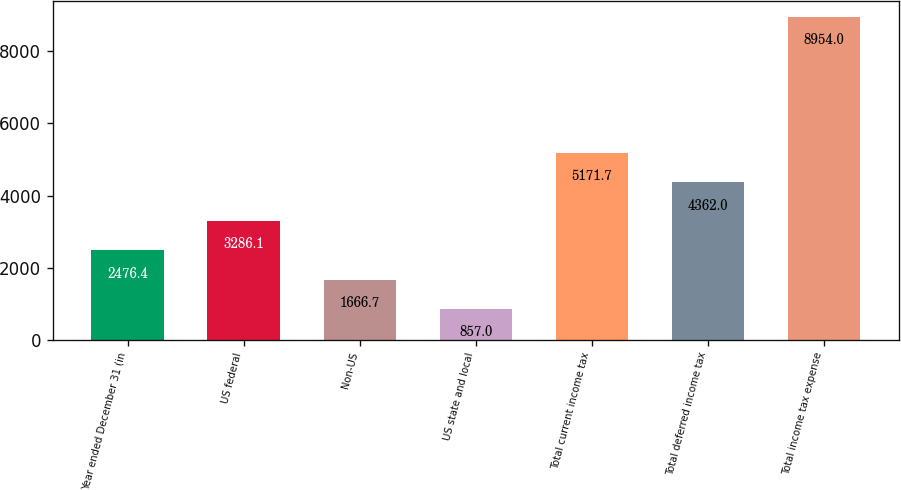<chart> <loc_0><loc_0><loc_500><loc_500><bar_chart><fcel>Year ended December 31 (in<fcel>US federal<fcel>Non-US<fcel>US state and local<fcel>Total current income tax<fcel>Total deferred income tax<fcel>Total income tax expense<nl><fcel>2476.4<fcel>3286.1<fcel>1666.7<fcel>857<fcel>5171.7<fcel>4362<fcel>8954<nl></chart> 